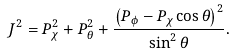<formula> <loc_0><loc_0><loc_500><loc_500>J ^ { 2 } = P _ { \chi } ^ { 2 } + P _ { \theta } ^ { 2 } + \frac { \left ( P _ { \phi } - P _ { \chi } \cos \theta \right ) ^ { 2 } } { \sin ^ { 2 } \theta } .</formula> 